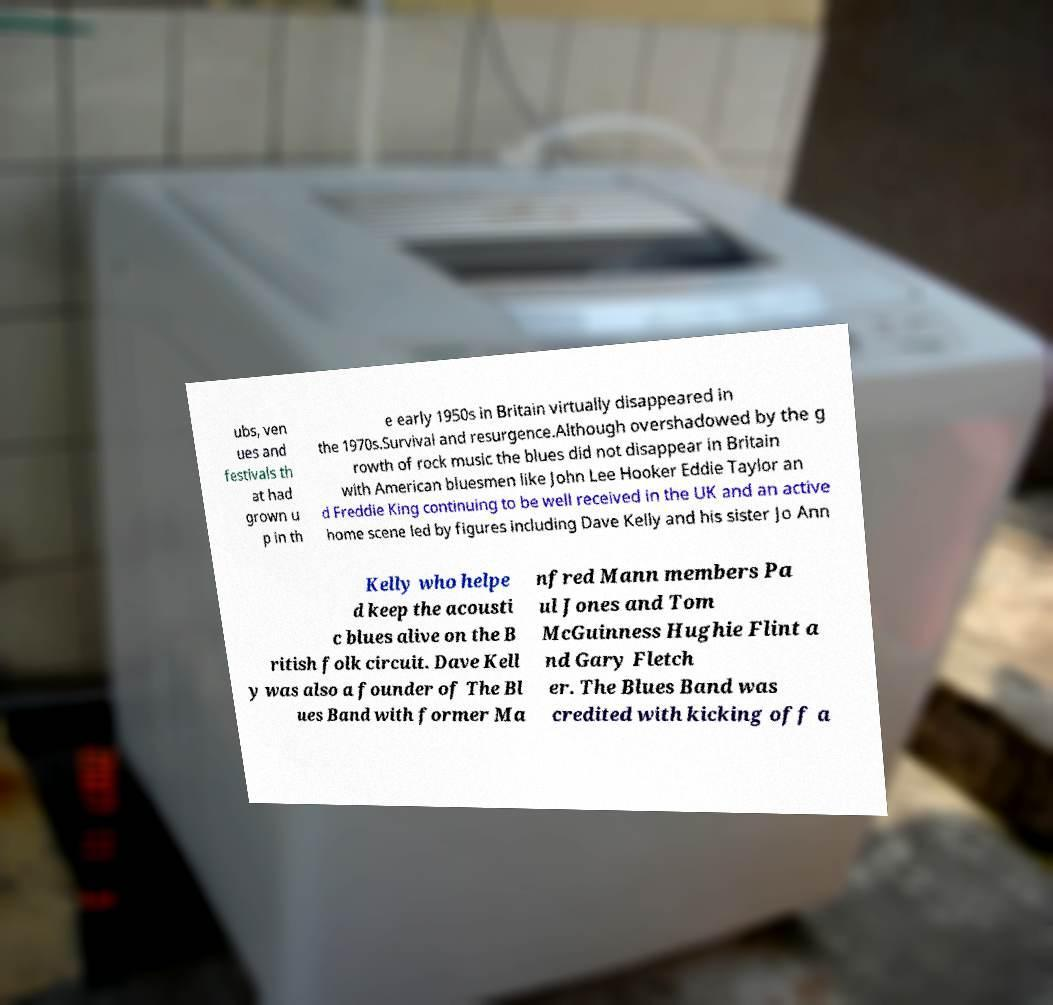Could you extract and type out the text from this image? ubs, ven ues and festivals th at had grown u p in th e early 1950s in Britain virtually disappeared in the 1970s.Survival and resurgence.Although overshadowed by the g rowth of rock music the blues did not disappear in Britain with American bluesmen like John Lee Hooker Eddie Taylor an d Freddie King continuing to be well received in the UK and an active home scene led by figures including Dave Kelly and his sister Jo Ann Kelly who helpe d keep the acousti c blues alive on the B ritish folk circuit. Dave Kell y was also a founder of The Bl ues Band with former Ma nfred Mann members Pa ul Jones and Tom McGuinness Hughie Flint a nd Gary Fletch er. The Blues Band was credited with kicking off a 